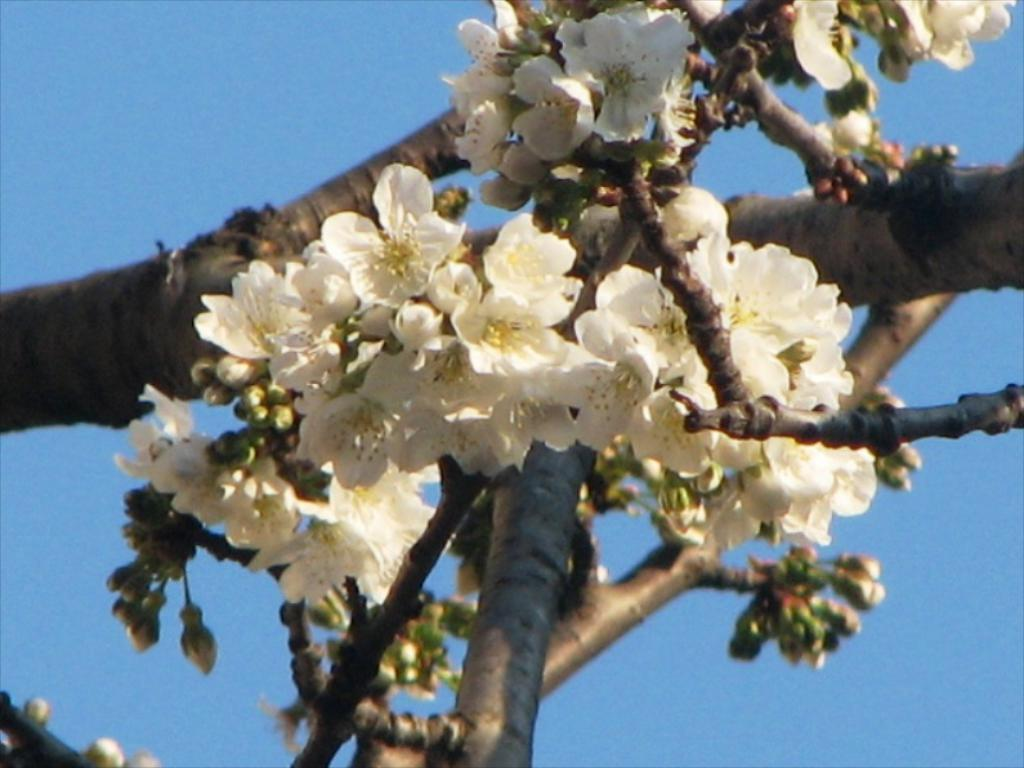What type of plant can be seen in the image? There is a tree in the image. What is growing on the tree? There are flowers on the tree. What colors are the flowers? The flowers are cream and yellow in color. What can be seen in the background of the image? The sky is visible in the background of the image. How does the tiger compare to the tree in the image? There is no tiger present in the image, so it cannot be compared to the tree. 